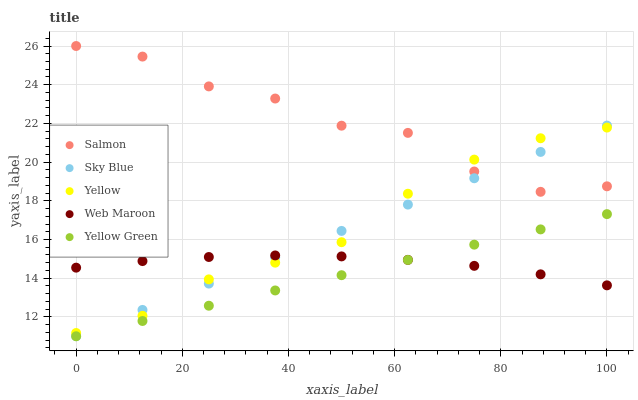Does Yellow Green have the minimum area under the curve?
Answer yes or no. Yes. Does Salmon have the maximum area under the curve?
Answer yes or no. Yes. Does Sky Blue have the minimum area under the curve?
Answer yes or no. No. Does Sky Blue have the maximum area under the curve?
Answer yes or no. No. Is Yellow Green the smoothest?
Answer yes or no. Yes. Is Salmon the roughest?
Answer yes or no. Yes. Is Sky Blue the smoothest?
Answer yes or no. No. Is Sky Blue the roughest?
Answer yes or no. No. Does Sky Blue have the lowest value?
Answer yes or no. Yes. Does Salmon have the lowest value?
Answer yes or no. No. Does Salmon have the highest value?
Answer yes or no. Yes. Does Sky Blue have the highest value?
Answer yes or no. No. Is Yellow Green less than Salmon?
Answer yes or no. Yes. Is Yellow greater than Yellow Green?
Answer yes or no. Yes. Does Sky Blue intersect Yellow?
Answer yes or no. Yes. Is Sky Blue less than Yellow?
Answer yes or no. No. Is Sky Blue greater than Yellow?
Answer yes or no. No. Does Yellow Green intersect Salmon?
Answer yes or no. No. 